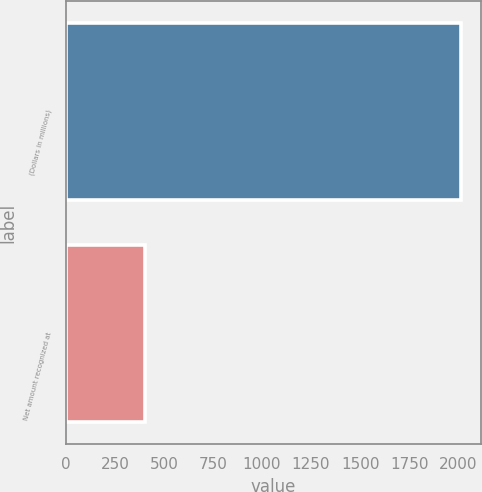Convert chart to OTSL. <chart><loc_0><loc_0><loc_500><loc_500><bar_chart><fcel>(Dollars in millions)<fcel>Net amount recognized at<nl><fcel>2014<fcel>402<nl></chart> 